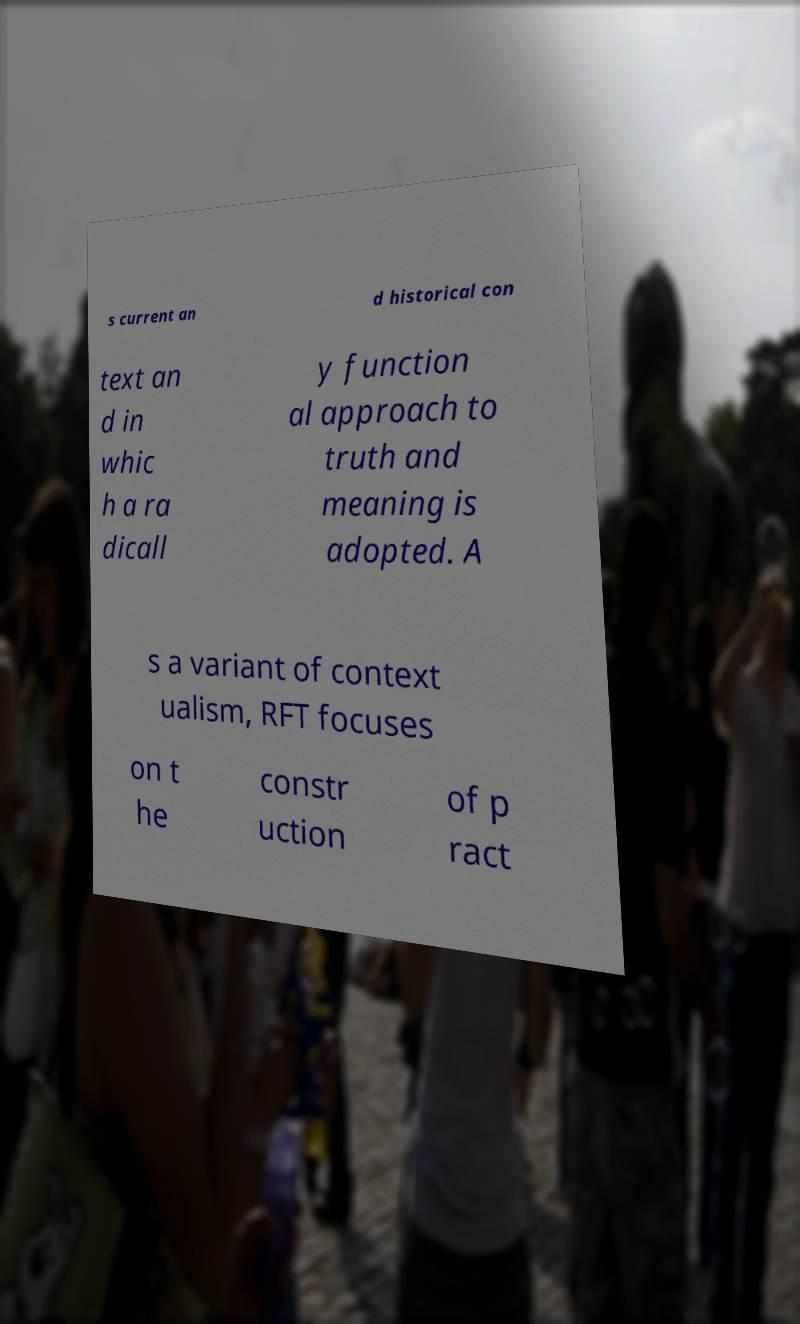Could you extract and type out the text from this image? s current an d historical con text an d in whic h a ra dicall y function al approach to truth and meaning is adopted. A s a variant of context ualism, RFT focuses on t he constr uction of p ract 